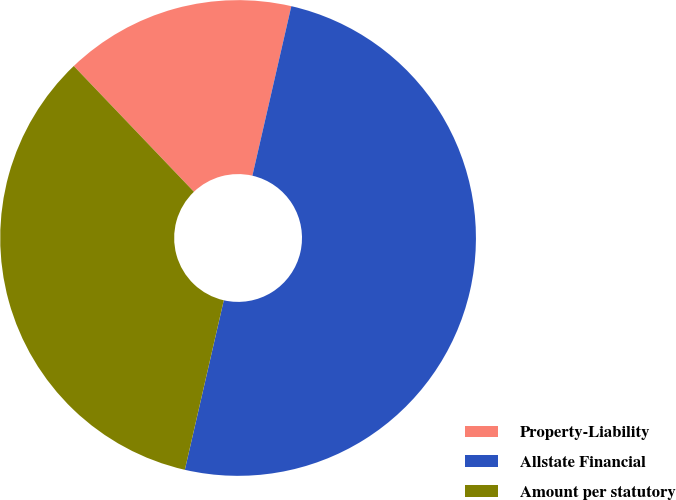Convert chart. <chart><loc_0><loc_0><loc_500><loc_500><pie_chart><fcel>Property-Liability<fcel>Allstate Financial<fcel>Amount per statutory<nl><fcel>15.73%<fcel>50.0%<fcel>34.27%<nl></chart> 